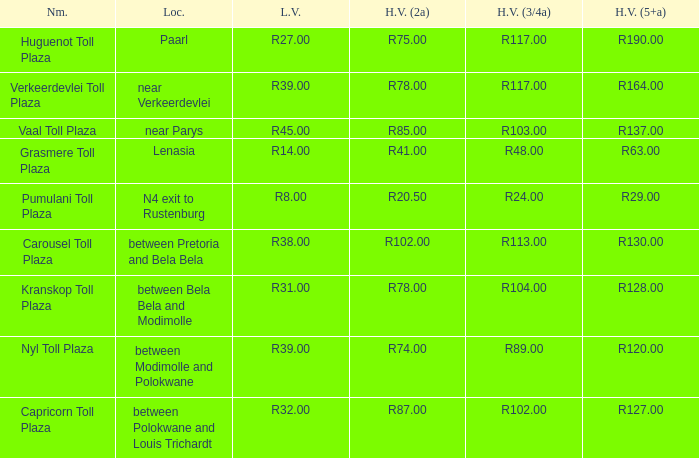What is the name of the plaza where the told for heavy vehicles with 2 axles is r20.50? Pumulani Toll Plaza. 